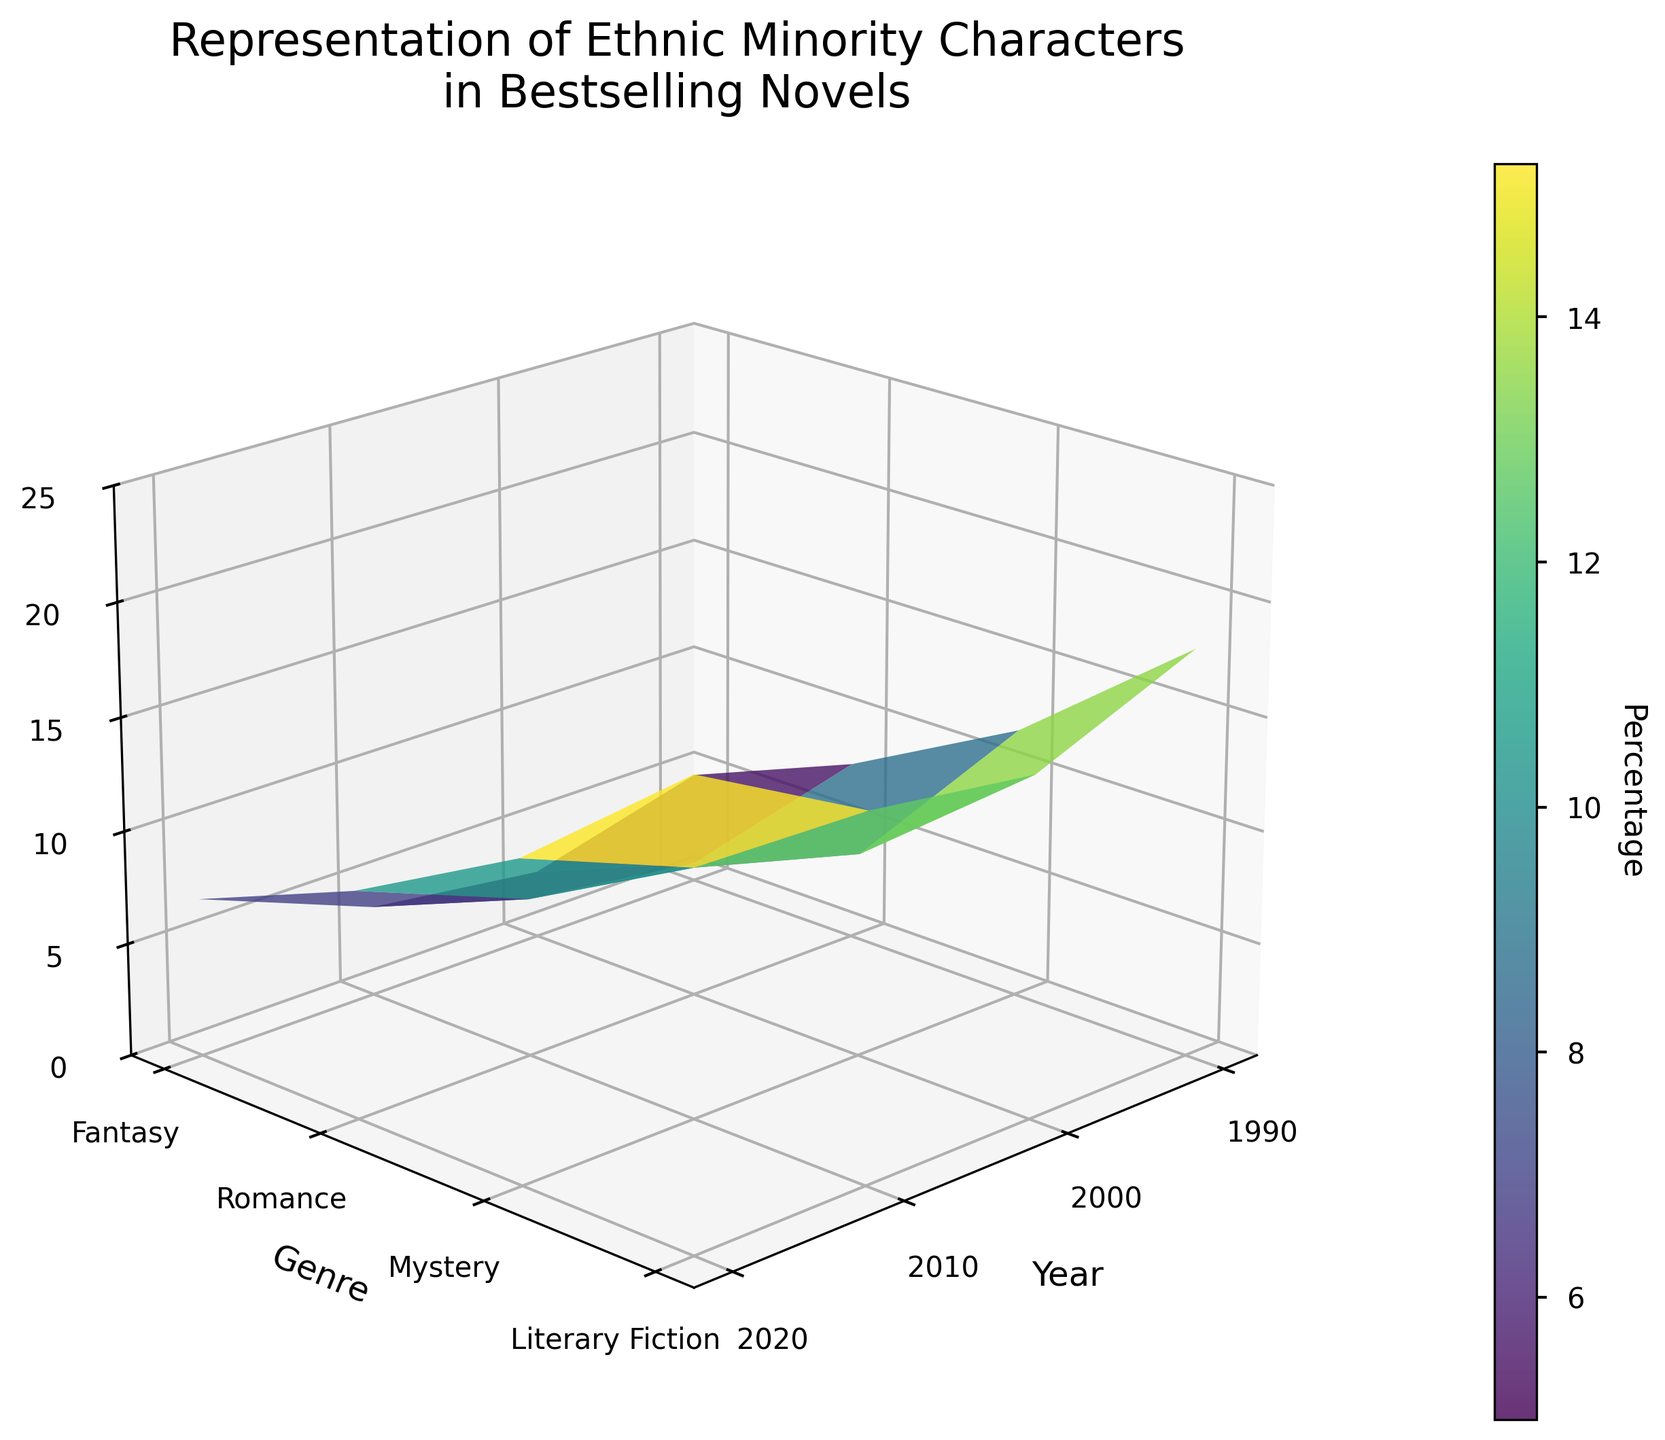What is the title of the figure? The title is written at the top of the 3D surface plot. It typically provides a summary of what the figure is about. In this case, the title reads "Representation of Ethnic Minority Characters in Bestselling Novels."
Answer: Representation of Ethnic Minority Characters in Bestselling Novels What are the labels for the x, y, and z axes? The x-axis label is at the bottom of the horizontal axis, the y-axis label is along the side of the vertical axis, and the z-axis label is along the depth axis. The labels for the axes are: x-axis is "Year," y-axis is "Genre," and z-axis is "Percentage."
Answer: Year, Genre, Percentage What is the percentage of ethnic minority characters in Fantasy novels in the year 2020? By looking at the 3D surface plot, identify the point at 2020 on the x-axis and Fantasy on the y-axis, then follow it to the corresponding height on the z-axis. The value is labeled as 18%.
Answer: 18% How has the representation of ethnic minority characters in Romance novels changed from 1990 to 2020? Identify the positions of Romance novels on the y-axis for the years 1990 and 2020 on the x-axis. Note the corresponding z-axis percentages: 3% in 1990 and 15% in 2020. Calculate the difference: 15% - 3% = 12%.
Answer: Increased by 12% Which genre had the highest percentage of ethnic minority characters in 2010? Identify the year 2010 on the x-axis, then compare the percentages of all genres on the y-axis for that year. Literary Fiction has the highest percentage with 14%.
Answer: Literary Fiction Which genre showed the most significant increase in percentage of ethnic minority characters from 1990 to 2020? Compare the percentages of each genre for the years 1990 and 2020. Calculate the differences: Fantasy (18% - 5% = 13%), Romance (15% - 3% = 12%), Mystery (16% - 4% = 12%), Literary Fiction (20% - 7% = 13%). Both Fantasy and Literary Fiction show the most significant increase of 13%.
Answer: Fantasy, Literary Fiction What is the average percentage of ethnic minority characters in Mystery novels from 1990 to 2020? Identify the percentages of Mystery novels for all listed years: 4% in 1990, 7% in 2000, 11% in 2010, and 16% in 2020. Calculate their average: (4% + 7% + 11% + 16%) / 4 = 9.5%.
Answer: 9.5% Does the plot show an overall increase or decrease in the representation of ethnic minority characters over the years? Observe the trend in the z-values over the years on the x-axis. All genres show an increasing trend in percentages of ethnic minority characters.
Answer: Increase 